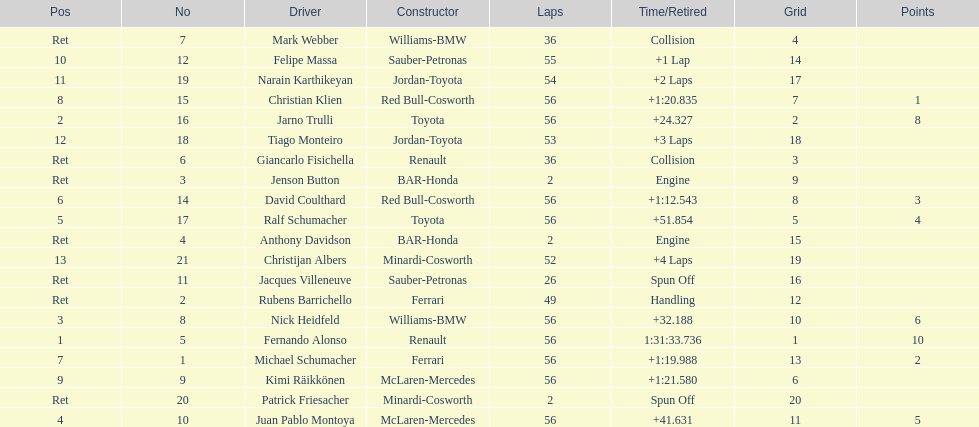How long did it take for heidfeld to finish? 1:31:65.924. Parse the full table. {'header': ['Pos', 'No', 'Driver', 'Constructor', 'Laps', 'Time/Retired', 'Grid', 'Points'], 'rows': [['Ret', '7', 'Mark Webber', 'Williams-BMW', '36', 'Collision', '4', ''], ['10', '12', 'Felipe Massa', 'Sauber-Petronas', '55', '+1 Lap', '14', ''], ['11', '19', 'Narain Karthikeyan', 'Jordan-Toyota', '54', '+2 Laps', '17', ''], ['8', '15', 'Christian Klien', 'Red Bull-Cosworth', '56', '+1:20.835', '7', '1'], ['2', '16', 'Jarno Trulli', 'Toyota', '56', '+24.327', '2', '8'], ['12', '18', 'Tiago Monteiro', 'Jordan-Toyota', '53', '+3 Laps', '18', ''], ['Ret', '6', 'Giancarlo Fisichella', 'Renault', '36', 'Collision', '3', ''], ['Ret', '3', 'Jenson Button', 'BAR-Honda', '2', 'Engine', '9', ''], ['6', '14', 'David Coulthard', 'Red Bull-Cosworth', '56', '+1:12.543', '8', '3'], ['5', '17', 'Ralf Schumacher', 'Toyota', '56', '+51.854', '5', '4'], ['Ret', '4', 'Anthony Davidson', 'BAR-Honda', '2', 'Engine', '15', ''], ['13', '21', 'Christijan Albers', 'Minardi-Cosworth', '52', '+4 Laps', '19', ''], ['Ret', '11', 'Jacques Villeneuve', 'Sauber-Petronas', '26', 'Spun Off', '16', ''], ['Ret', '2', 'Rubens Barrichello', 'Ferrari', '49', 'Handling', '12', ''], ['3', '8', 'Nick Heidfeld', 'Williams-BMW', '56', '+32.188', '10', '6'], ['1', '5', 'Fernando Alonso', 'Renault', '56', '1:31:33.736', '1', '10'], ['7', '1', 'Michael Schumacher', 'Ferrari', '56', '+1:19.988', '13', '2'], ['9', '9', 'Kimi Räikkönen', 'McLaren-Mercedes', '56', '+1:21.580', '6', ''], ['Ret', '20', 'Patrick Friesacher', 'Minardi-Cosworth', '2', 'Spun Off', '20', ''], ['4', '10', 'Juan Pablo Montoya', 'McLaren-Mercedes', '56', '+41.631', '11', '5']]} 